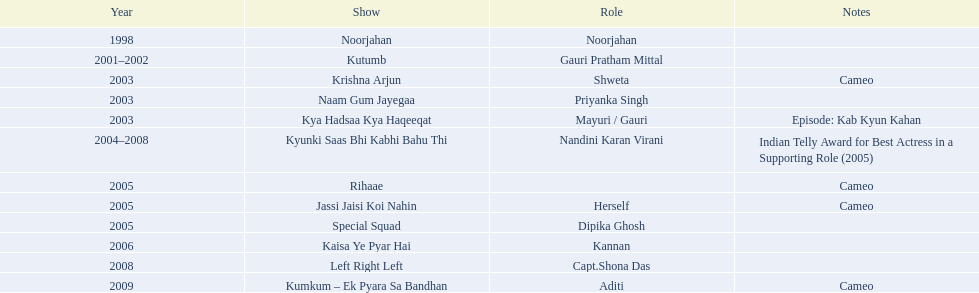What shows did gauri pradhan tejwani star in? Noorjahan, Kutumb, Krishna Arjun, Naam Gum Jayegaa, Kya Hadsaa Kya Haqeeqat, Kyunki Saas Bhi Kabhi Bahu Thi, Rihaae, Jassi Jaisi Koi Nahin, Special Squad, Kaisa Ye Pyar Hai, Left Right Left, Kumkum – Ek Pyara Sa Bandhan. Of these, which were cameos? Krishna Arjun, Rihaae, Jassi Jaisi Koi Nahin, Kumkum – Ek Pyara Sa Bandhan. Of these, in which did she play the role of herself? Jassi Jaisi Koi Nahin. 